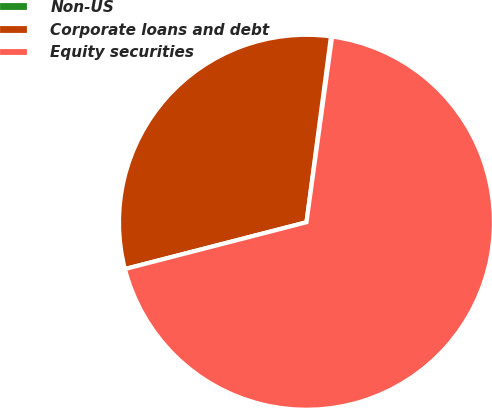Convert chart. <chart><loc_0><loc_0><loc_500><loc_500><pie_chart><fcel>Non-US<fcel>Corporate loans and debt<fcel>Equity securities<nl><fcel>0.1%<fcel>31.1%<fcel>68.8%<nl></chart> 